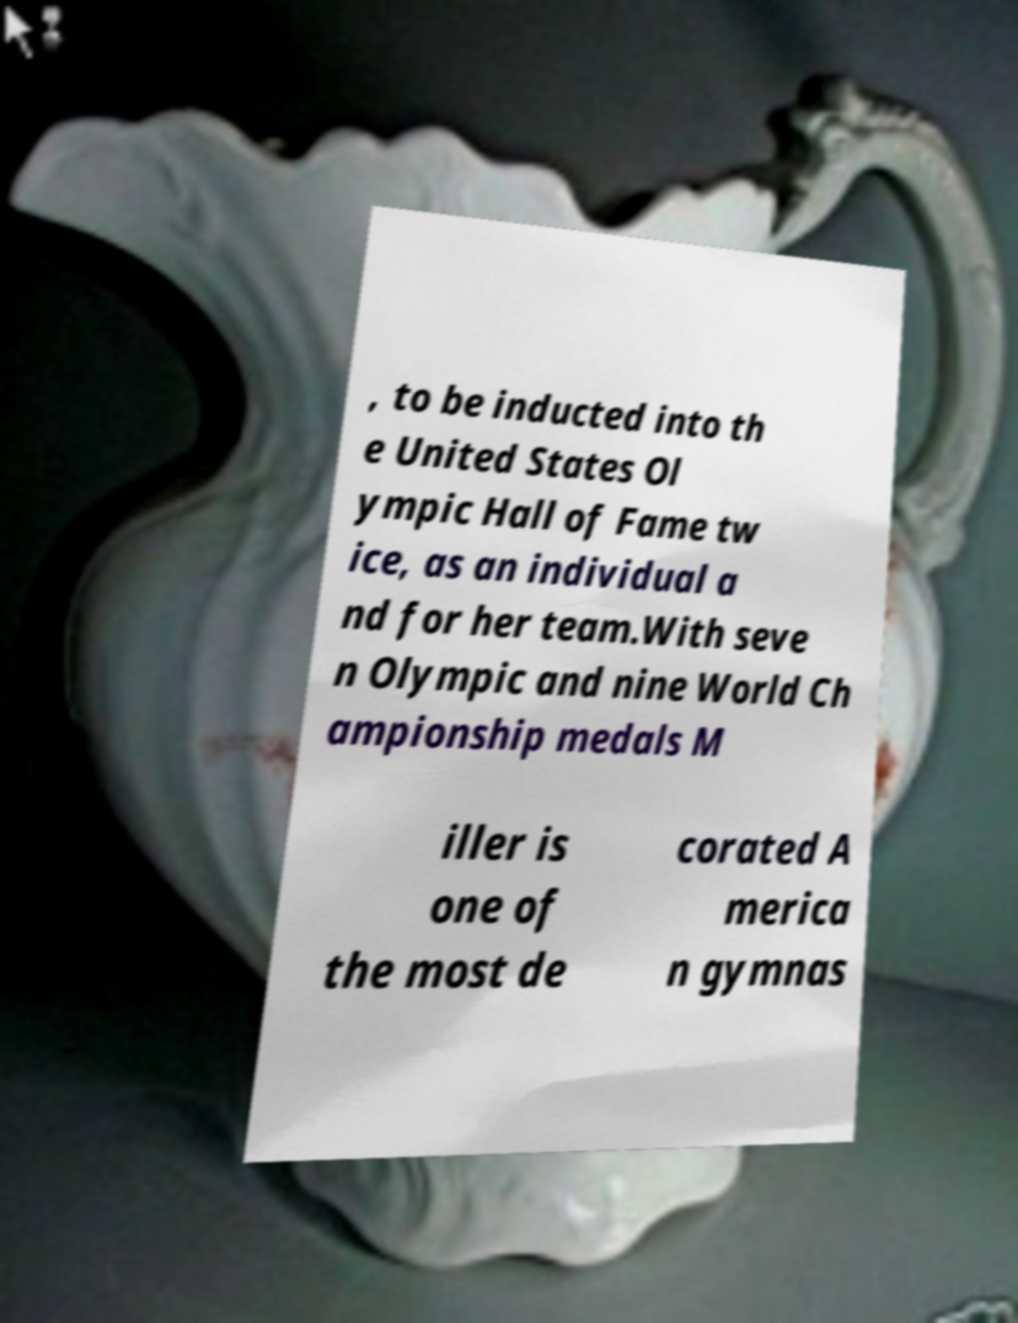Please read and relay the text visible in this image. What does it say? , to be inducted into th e United States Ol ympic Hall of Fame tw ice, as an individual a nd for her team.With seve n Olympic and nine World Ch ampionship medals M iller is one of the most de corated A merica n gymnas 